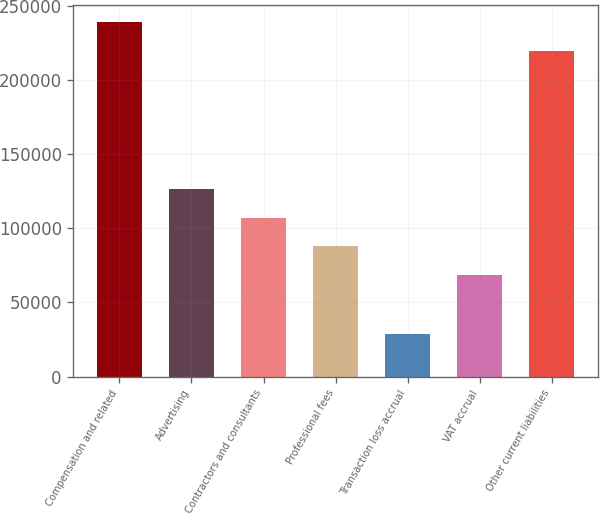Convert chart. <chart><loc_0><loc_0><loc_500><loc_500><bar_chart><fcel>Compensation and related<fcel>Advertising<fcel>Contractors and consultants<fcel>Professional fees<fcel>Transaction loss accrual<fcel>VAT accrual<fcel>Other current liabilities<nl><fcel>238854<fcel>126444<fcel>107144<fcel>87842.8<fcel>28506<fcel>68542<fcel>219553<nl></chart> 